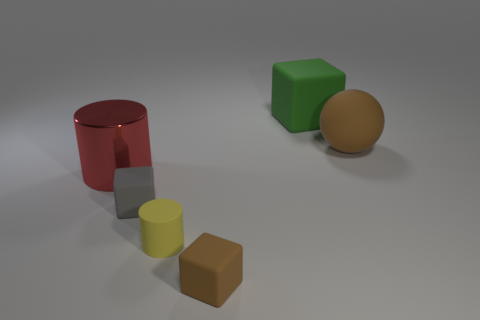Subtract all large green matte cubes. How many cubes are left? 2 Add 2 large shiny cylinders. How many objects exist? 8 Subtract 2 blocks. How many blocks are left? 1 Subtract all red cylinders. How many cylinders are left? 1 Add 2 large green shiny cubes. How many large green shiny cubes exist? 2 Subtract 0 red cubes. How many objects are left? 6 Subtract all balls. How many objects are left? 5 Subtract all brown cubes. Subtract all green cylinders. How many cubes are left? 2 Subtract all blue cylinders. How many blue cubes are left? 0 Subtract all green rubber objects. Subtract all large green rubber blocks. How many objects are left? 4 